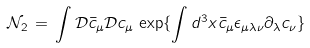<formula> <loc_0><loc_0><loc_500><loc_500>{ \mathcal { N } } _ { 2 } \, = \, \int { \mathcal { D } } { \bar { c } } _ { \mu } { \mathcal { D } } c _ { \mu } \, \exp \{ \int d ^ { 3 } x { \bar { c } } _ { \mu } \epsilon _ { \mu \lambda \nu } \partial _ { \lambda } c _ { \nu } \}</formula> 